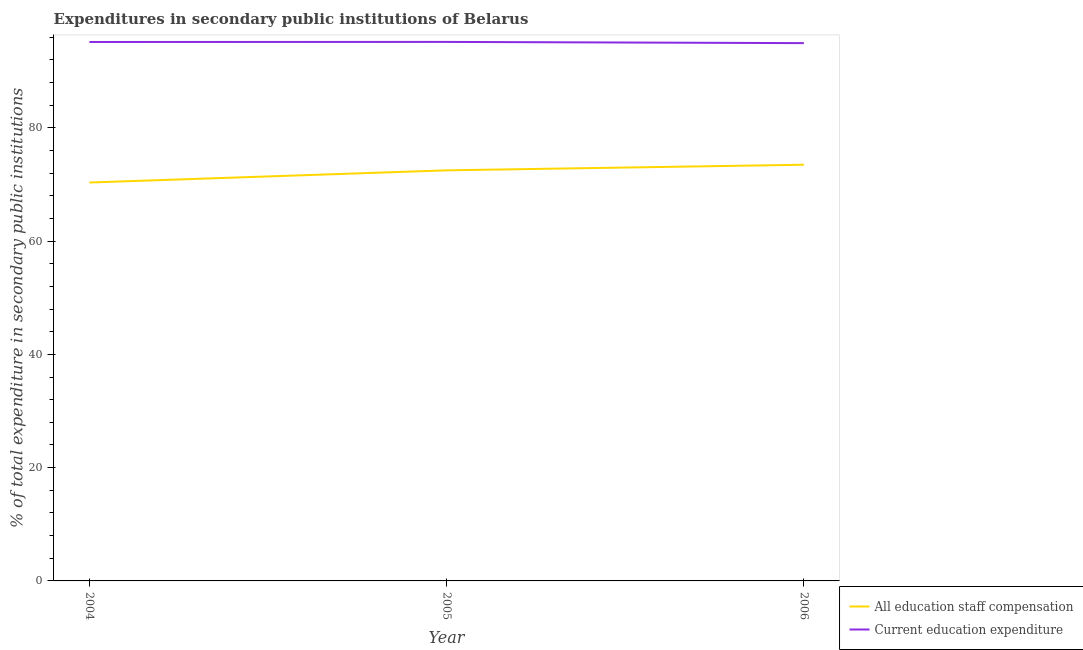Is the number of lines equal to the number of legend labels?
Offer a terse response. Yes. What is the expenditure in staff compensation in 2005?
Ensure brevity in your answer.  72.49. Across all years, what is the maximum expenditure in education?
Make the answer very short. 95.17. Across all years, what is the minimum expenditure in staff compensation?
Your response must be concise. 70.34. In which year was the expenditure in education maximum?
Offer a terse response. 2005. What is the total expenditure in education in the graph?
Make the answer very short. 285.29. What is the difference between the expenditure in staff compensation in 2004 and that in 2006?
Provide a short and direct response. -3.14. What is the difference between the expenditure in staff compensation in 2004 and the expenditure in education in 2006?
Give a very brief answer. -24.61. What is the average expenditure in education per year?
Provide a succinct answer. 95.1. In the year 2005, what is the difference between the expenditure in education and expenditure in staff compensation?
Give a very brief answer. 22.68. In how many years, is the expenditure in staff compensation greater than 36 %?
Give a very brief answer. 3. What is the ratio of the expenditure in education in 2004 to that in 2005?
Your response must be concise. 1. Is the expenditure in education in 2004 less than that in 2005?
Provide a succinct answer. Yes. Is the difference between the expenditure in staff compensation in 2005 and 2006 greater than the difference between the expenditure in education in 2005 and 2006?
Offer a terse response. No. What is the difference between the highest and the second highest expenditure in staff compensation?
Your response must be concise. 0.99. What is the difference between the highest and the lowest expenditure in education?
Your answer should be very brief. 0.21. Is the sum of the expenditure in staff compensation in 2004 and 2005 greater than the maximum expenditure in education across all years?
Make the answer very short. Yes. Does the expenditure in staff compensation monotonically increase over the years?
Your answer should be very brief. Yes. Is the expenditure in staff compensation strictly greater than the expenditure in education over the years?
Your answer should be compact. No. How many lines are there?
Keep it short and to the point. 2. How many years are there in the graph?
Ensure brevity in your answer.  3. What is the difference between two consecutive major ticks on the Y-axis?
Your response must be concise. 20. Does the graph contain any zero values?
Ensure brevity in your answer.  No. Does the graph contain grids?
Provide a succinct answer. No. How are the legend labels stacked?
Make the answer very short. Vertical. What is the title of the graph?
Make the answer very short. Expenditures in secondary public institutions of Belarus. Does "Age 15+" appear as one of the legend labels in the graph?
Your answer should be very brief. No. What is the label or title of the Y-axis?
Keep it short and to the point. % of total expenditure in secondary public institutions. What is the % of total expenditure in secondary public institutions in All education staff compensation in 2004?
Give a very brief answer. 70.34. What is the % of total expenditure in secondary public institutions of Current education expenditure in 2004?
Keep it short and to the point. 95.16. What is the % of total expenditure in secondary public institutions of All education staff compensation in 2005?
Offer a terse response. 72.49. What is the % of total expenditure in secondary public institutions in Current education expenditure in 2005?
Offer a terse response. 95.17. What is the % of total expenditure in secondary public institutions of All education staff compensation in 2006?
Give a very brief answer. 73.49. What is the % of total expenditure in secondary public institutions in Current education expenditure in 2006?
Your answer should be compact. 94.96. Across all years, what is the maximum % of total expenditure in secondary public institutions in All education staff compensation?
Ensure brevity in your answer.  73.49. Across all years, what is the maximum % of total expenditure in secondary public institutions of Current education expenditure?
Offer a very short reply. 95.17. Across all years, what is the minimum % of total expenditure in secondary public institutions of All education staff compensation?
Your response must be concise. 70.34. Across all years, what is the minimum % of total expenditure in secondary public institutions of Current education expenditure?
Make the answer very short. 94.96. What is the total % of total expenditure in secondary public institutions in All education staff compensation in the graph?
Your answer should be compact. 216.32. What is the total % of total expenditure in secondary public institutions of Current education expenditure in the graph?
Provide a short and direct response. 285.29. What is the difference between the % of total expenditure in secondary public institutions of All education staff compensation in 2004 and that in 2005?
Your response must be concise. -2.15. What is the difference between the % of total expenditure in secondary public institutions in Current education expenditure in 2004 and that in 2005?
Provide a succinct answer. -0.01. What is the difference between the % of total expenditure in secondary public institutions in All education staff compensation in 2004 and that in 2006?
Your answer should be very brief. -3.14. What is the difference between the % of total expenditure in secondary public institutions in Current education expenditure in 2004 and that in 2006?
Provide a succinct answer. 0.2. What is the difference between the % of total expenditure in secondary public institutions in All education staff compensation in 2005 and that in 2006?
Offer a very short reply. -0.99. What is the difference between the % of total expenditure in secondary public institutions in Current education expenditure in 2005 and that in 2006?
Offer a terse response. 0.21. What is the difference between the % of total expenditure in secondary public institutions in All education staff compensation in 2004 and the % of total expenditure in secondary public institutions in Current education expenditure in 2005?
Provide a succinct answer. -24.83. What is the difference between the % of total expenditure in secondary public institutions in All education staff compensation in 2004 and the % of total expenditure in secondary public institutions in Current education expenditure in 2006?
Offer a very short reply. -24.61. What is the difference between the % of total expenditure in secondary public institutions of All education staff compensation in 2005 and the % of total expenditure in secondary public institutions of Current education expenditure in 2006?
Your answer should be very brief. -22.46. What is the average % of total expenditure in secondary public institutions of All education staff compensation per year?
Offer a very short reply. 72.11. What is the average % of total expenditure in secondary public institutions of Current education expenditure per year?
Offer a terse response. 95.1. In the year 2004, what is the difference between the % of total expenditure in secondary public institutions of All education staff compensation and % of total expenditure in secondary public institutions of Current education expenditure?
Offer a terse response. -24.82. In the year 2005, what is the difference between the % of total expenditure in secondary public institutions in All education staff compensation and % of total expenditure in secondary public institutions in Current education expenditure?
Offer a terse response. -22.68. In the year 2006, what is the difference between the % of total expenditure in secondary public institutions of All education staff compensation and % of total expenditure in secondary public institutions of Current education expenditure?
Your answer should be compact. -21.47. What is the ratio of the % of total expenditure in secondary public institutions in All education staff compensation in 2004 to that in 2005?
Your answer should be very brief. 0.97. What is the ratio of the % of total expenditure in secondary public institutions of Current education expenditure in 2004 to that in 2005?
Your response must be concise. 1. What is the ratio of the % of total expenditure in secondary public institutions of All education staff compensation in 2004 to that in 2006?
Your answer should be compact. 0.96. What is the ratio of the % of total expenditure in secondary public institutions in Current education expenditure in 2004 to that in 2006?
Offer a very short reply. 1. What is the ratio of the % of total expenditure in secondary public institutions in All education staff compensation in 2005 to that in 2006?
Provide a succinct answer. 0.99. What is the ratio of the % of total expenditure in secondary public institutions of Current education expenditure in 2005 to that in 2006?
Your response must be concise. 1. What is the difference between the highest and the second highest % of total expenditure in secondary public institutions in All education staff compensation?
Offer a terse response. 0.99. What is the difference between the highest and the second highest % of total expenditure in secondary public institutions in Current education expenditure?
Give a very brief answer. 0.01. What is the difference between the highest and the lowest % of total expenditure in secondary public institutions in All education staff compensation?
Your answer should be compact. 3.14. What is the difference between the highest and the lowest % of total expenditure in secondary public institutions in Current education expenditure?
Provide a succinct answer. 0.21. 